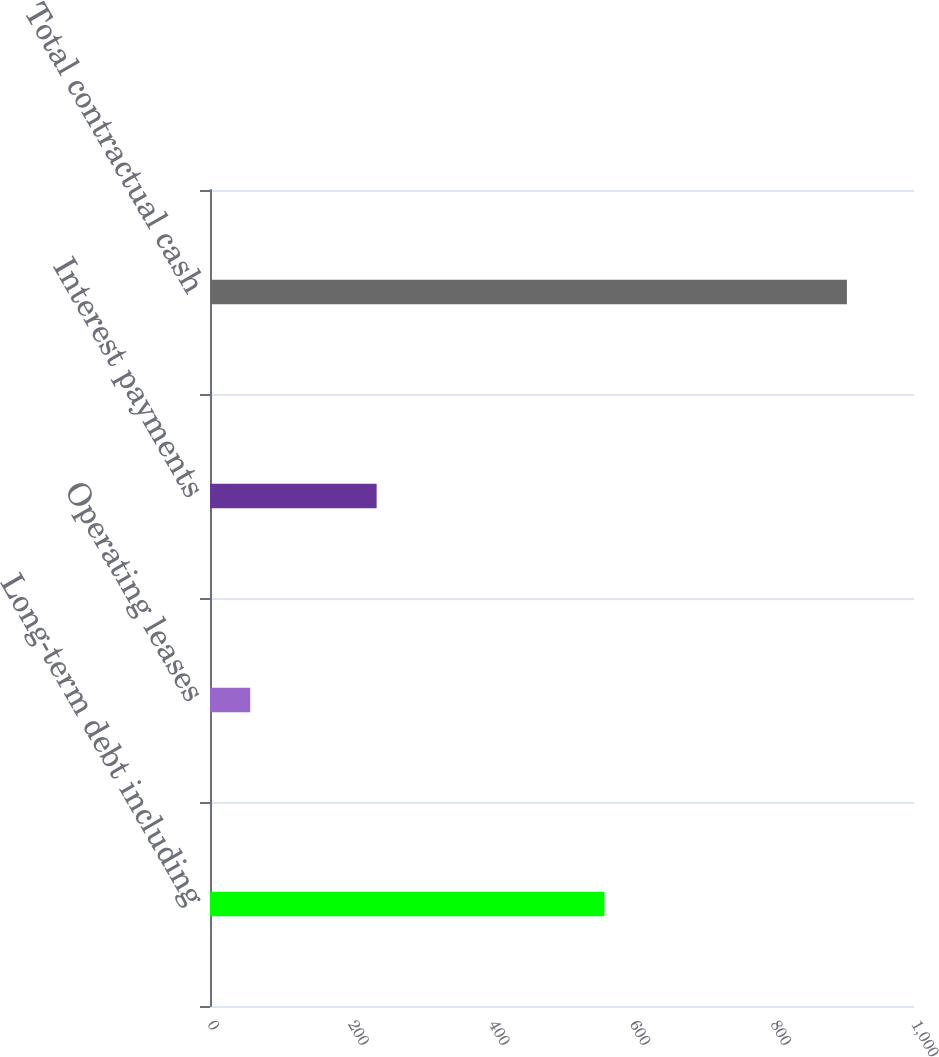<chart> <loc_0><loc_0><loc_500><loc_500><bar_chart><fcel>Long-term debt including<fcel>Operating leases<fcel>Interest payments<fcel>Total contractual cash<nl><fcel>560.3<fcel>57.1<fcel>236.7<fcel>904.7<nl></chart> 